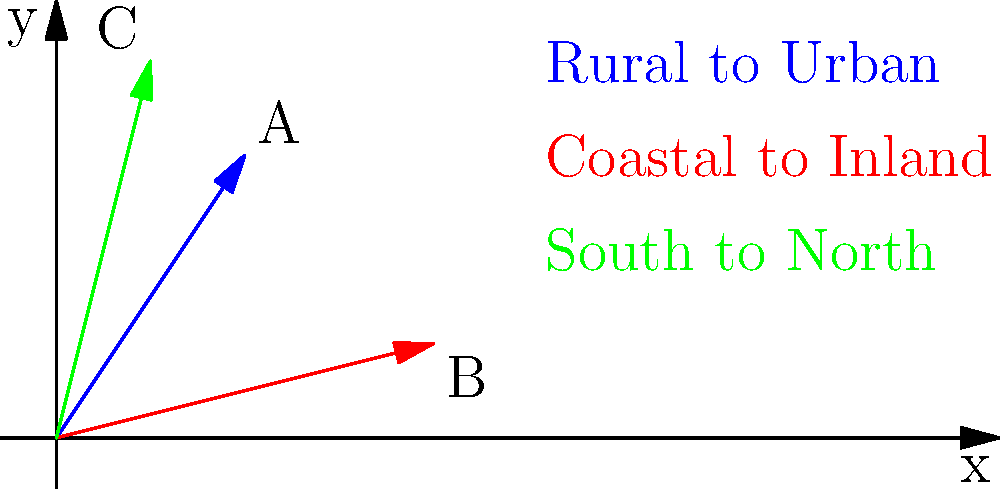In the given coordinate plane, three vectors represent different historical migration patterns during the Industrial Revolution. Vector A (blue) shows rural to urban migration, vector B (red) represents coastal to inland movement, and vector C (green) indicates south to north migration. If these vectors are added together to form a resultant vector R, what are the coordinates of R's endpoint? To find the coordinates of the resultant vector R, we need to add the three given vectors:

1. Identify the coordinates of each vector:
   Vector A: (2, 3)
   Vector B: (4, 1)
   Vector C: (1, 4)

2. Add the x-components:
   $R_x = 2 + 4 + 1 = 7$

3. Add the y-components:
   $R_y = 3 + 1 + 4 = 8$

4. The resultant vector R is therefore:
   $R = (7, 8)$

This vector represents the combined effect of all three migration patterns, showing the overall trend of population movement during the Industrial Revolution.
Answer: (7, 8) 